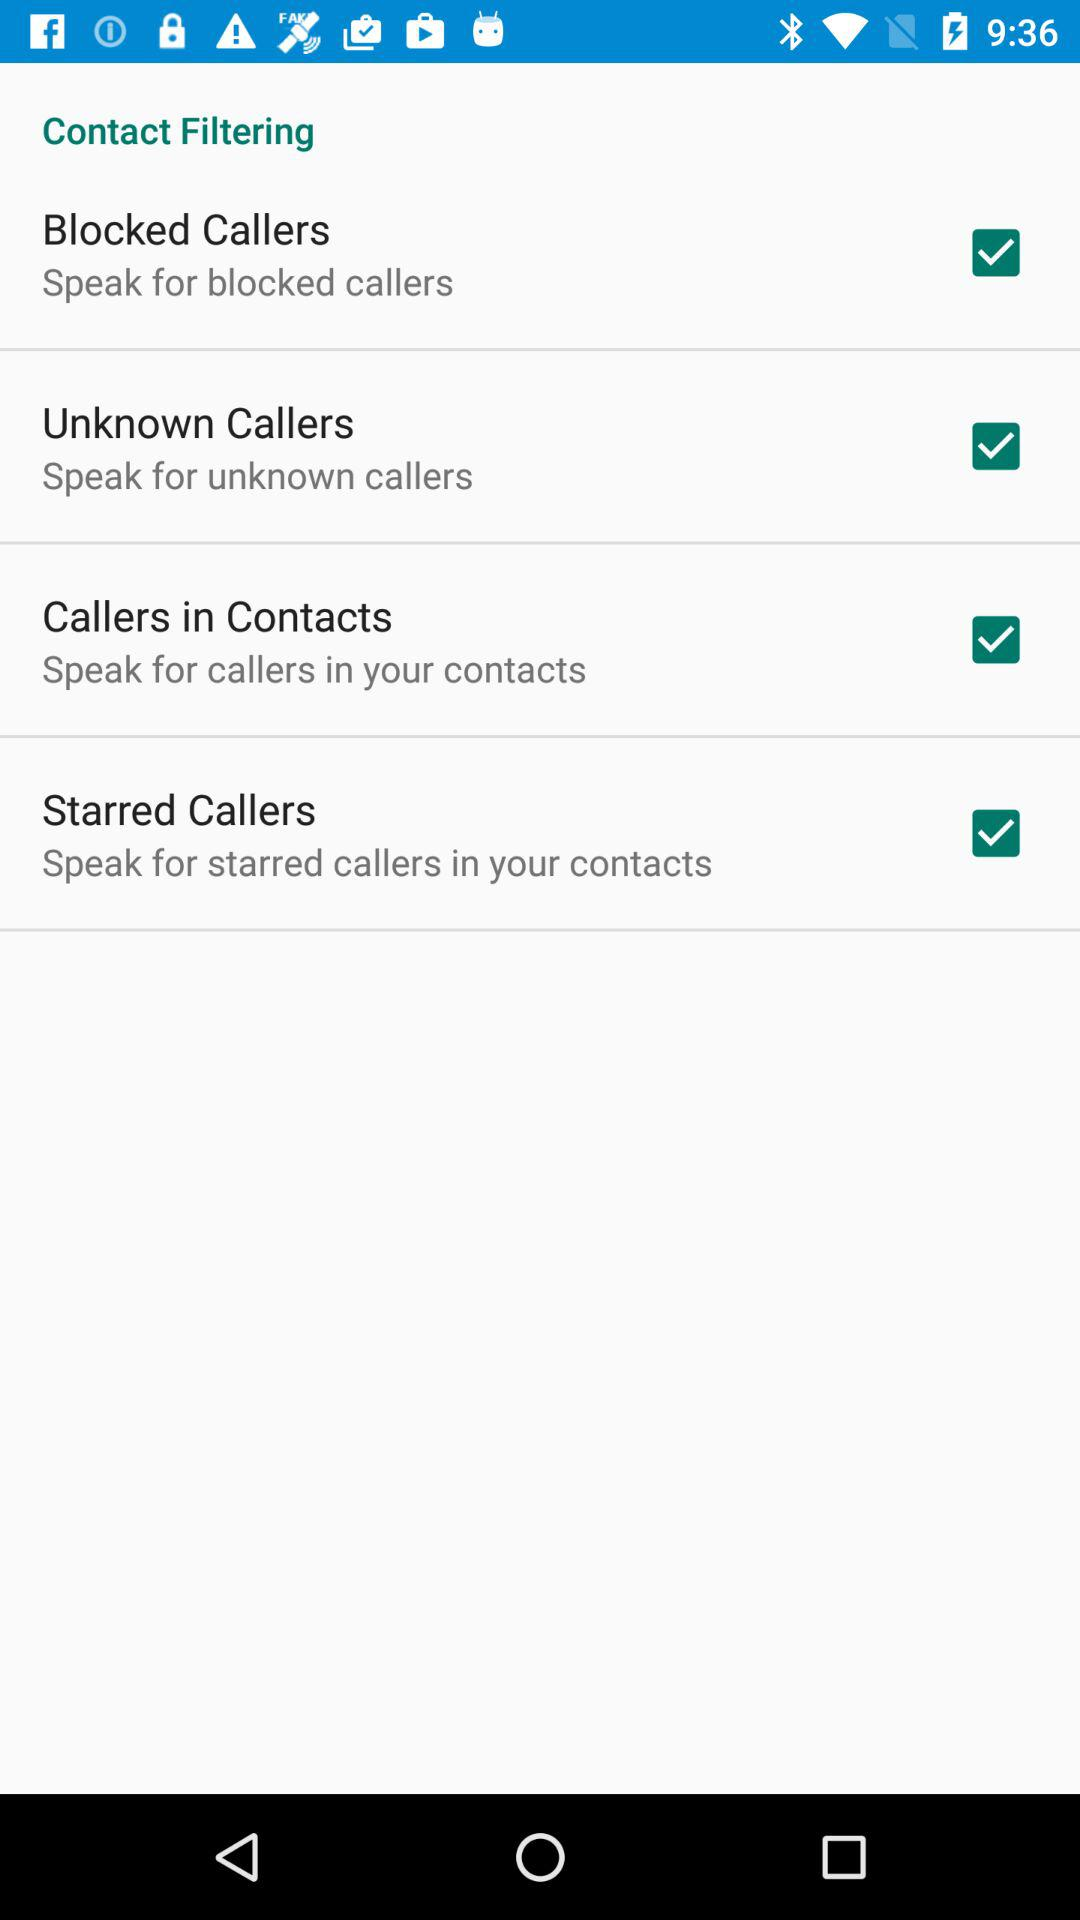What is the setting for "Callers in Contacts"? The setting is "Speak for callers in your contacts". 